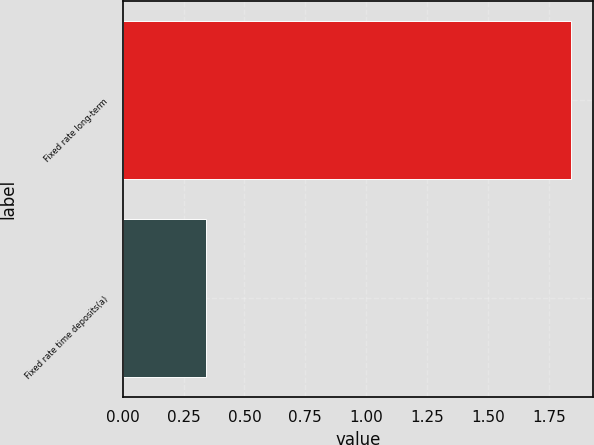Convert chart to OTSL. <chart><loc_0><loc_0><loc_500><loc_500><bar_chart><fcel>Fixed rate long-term<fcel>Fixed rate time deposits(a)<nl><fcel>1.84<fcel>0.34<nl></chart> 